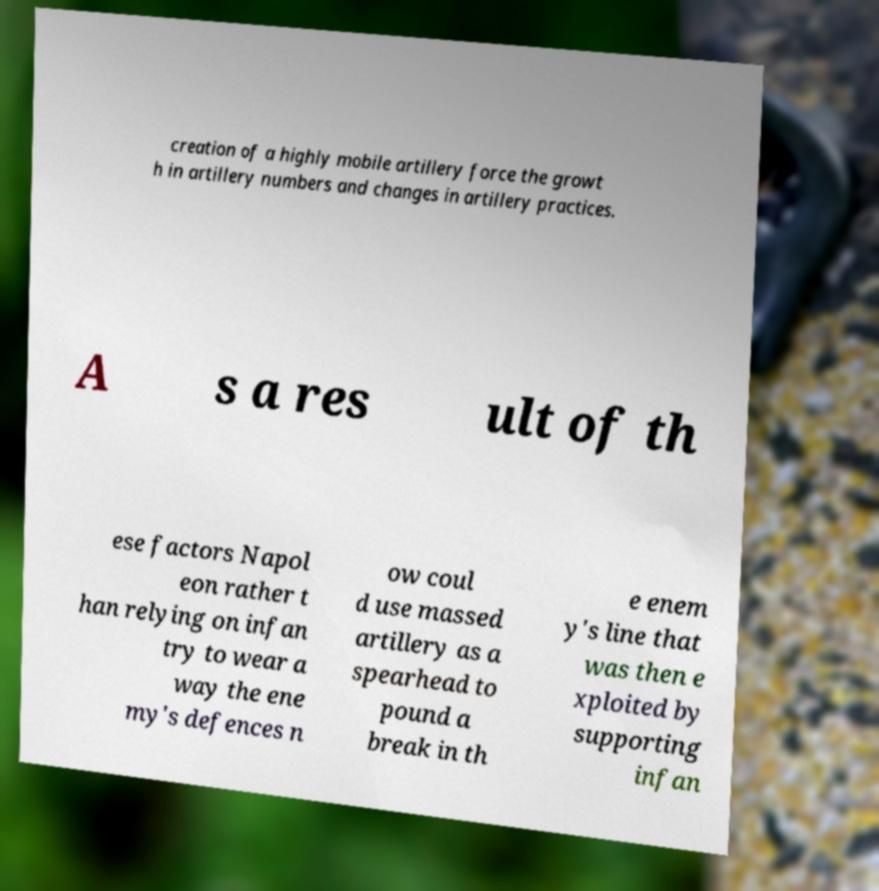Can you read and provide the text displayed in the image?This photo seems to have some interesting text. Can you extract and type it out for me? creation of a highly mobile artillery force the growt h in artillery numbers and changes in artillery practices. A s a res ult of th ese factors Napol eon rather t han relying on infan try to wear a way the ene my's defences n ow coul d use massed artillery as a spearhead to pound a break in th e enem y's line that was then e xploited by supporting infan 